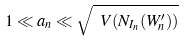Convert formula to latex. <formula><loc_0><loc_0><loc_500><loc_500>1 \ll a _ { n } \ll \sqrt { \ V ( N _ { I _ { n } } ( W _ { n } ^ { \prime } ) ) }</formula> 